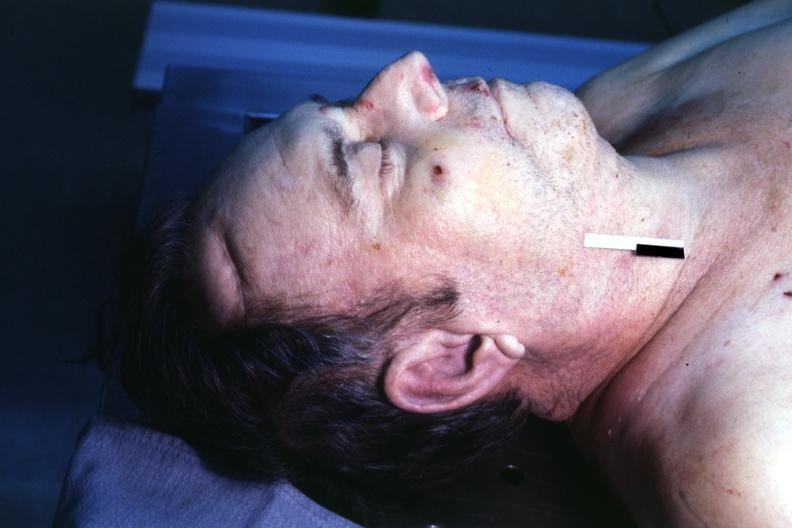s granulosa cell tumor easily seen?
Answer the question using a single word or phrase. No 